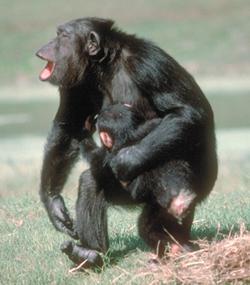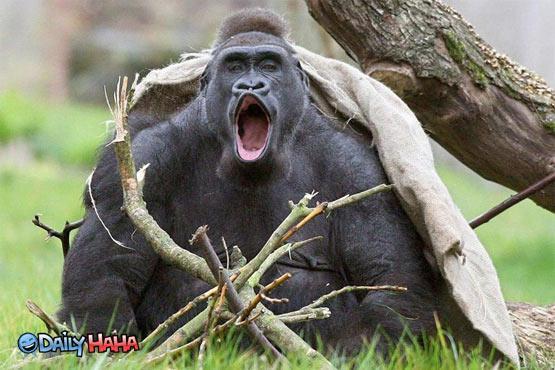The first image is the image on the left, the second image is the image on the right. Analyze the images presented: Is the assertion "One image has a single monkey who has his mouth open, with a visible tree in the background and green grass." valid? Answer yes or no. Yes. 